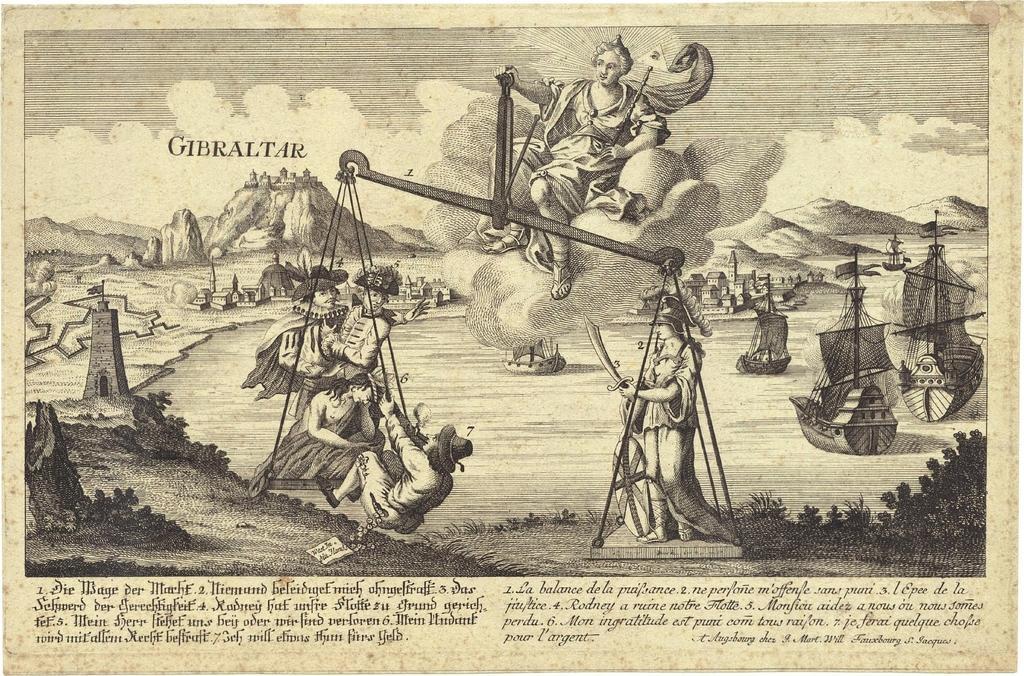Could you give a brief overview of what you see in this image? In this picture I can see the text at the bottom, in the middle a girl is balancing the weights. In the background there are hills. At the top there is the sky. 